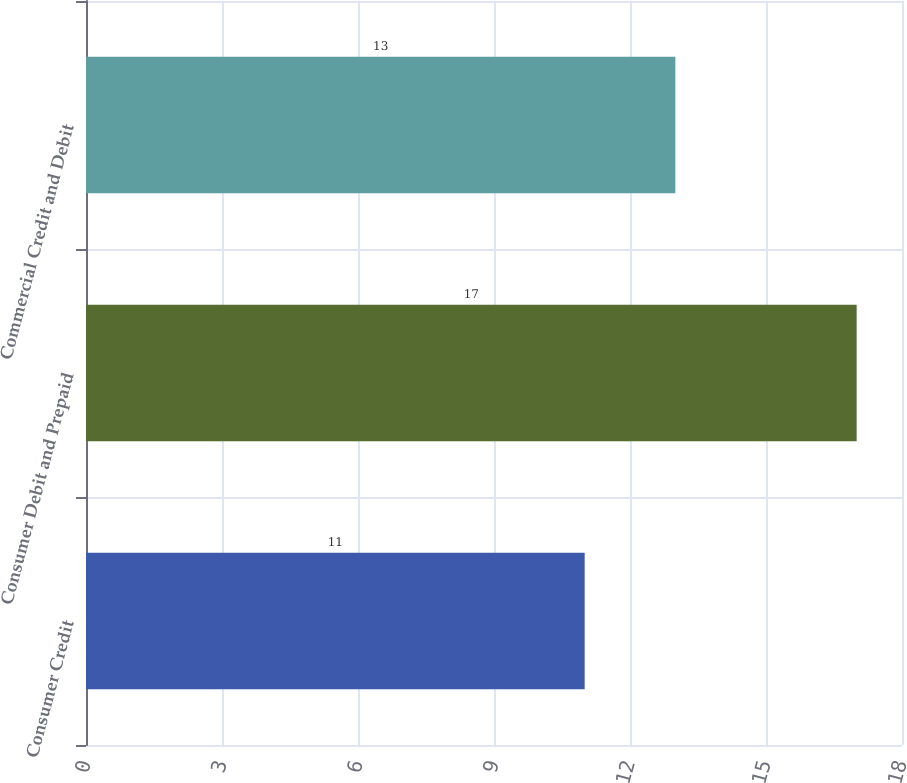<chart> <loc_0><loc_0><loc_500><loc_500><bar_chart><fcel>Consumer Credit<fcel>Consumer Debit and Prepaid<fcel>Commercial Credit and Debit<nl><fcel>11<fcel>17<fcel>13<nl></chart> 